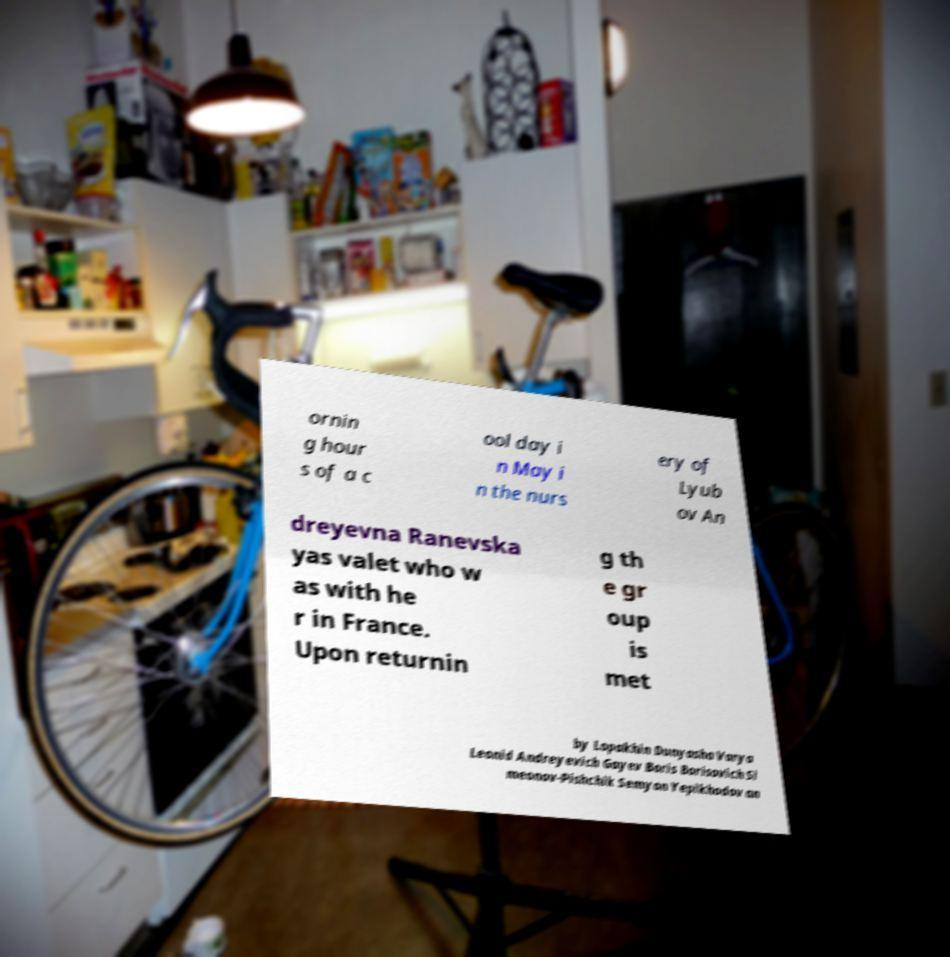Please read and relay the text visible in this image. What does it say? ornin g hour s of a c ool day i n May i n the nurs ery of Lyub ov An dreyevna Ranevska yas valet who w as with he r in France. Upon returnin g th e gr oup is met by Lopakhin Dunyasha Varya Leonid Andreyevich Gayev Boris Borisovich Si meonov-Pishchik Semyon Yepikhodov an 